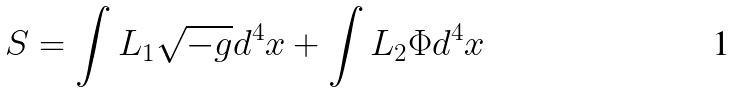Convert formula to latex. <formula><loc_0><loc_0><loc_500><loc_500>S = \int L _ { 1 } \sqrt { - g } d ^ { 4 } x + \int L _ { 2 } \Phi d ^ { 4 } x</formula> 